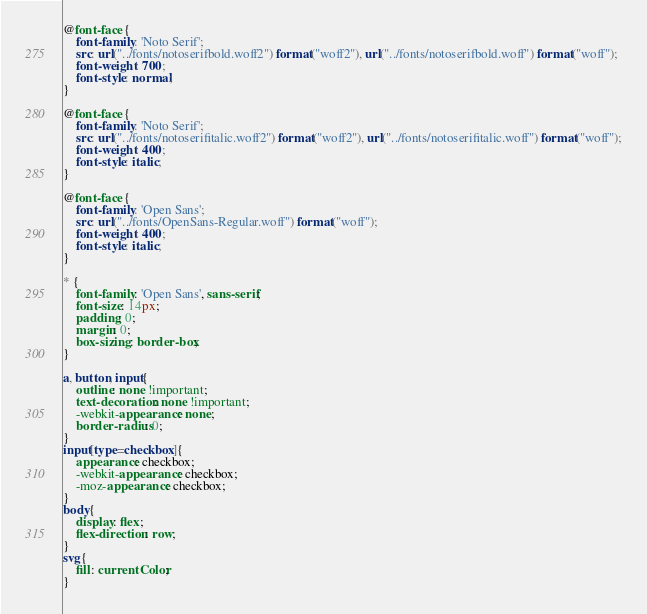Convert code to text. <code><loc_0><loc_0><loc_500><loc_500><_CSS_>@font-face {
    font-family: 'Noto Serif';
    src: url("../fonts/notoserifbold.woff2") format("woff2"), url("../fonts/notoserifbold.woff") format("woff");
    font-weight: 700;
    font-style: normal;
}

@font-face {
    font-family: 'Noto Serif';
    src: url("../fonts/notoserifitalic.woff2") format("woff2"), url("../fonts/notoserifitalic.woff") format("woff");
    font-weight: 400;
    font-style: italic;
}

@font-face {
    font-family: 'Open Sans';
    src: url("../fonts/OpenSans-Regular.woff") format("woff");
    font-weight: 400;
    font-style: italic;
}

* {
    font-family: 'Open Sans', sans-serif;
    font-size: 14px;
    padding: 0;
    margin: 0;
    box-sizing: border-box;
}

a, button, input{
    outline: none !important;
    text-decoration: none !important;
    -webkit-appearance: none;
    border-radius: 0;
}
input[type=checkbox]{
    appearance: checkbox;
    -webkit-appearance: checkbox;
    -moz-appearance: checkbox;
}
body{
    display: flex;
    flex-direction: row;
}
svg{
    fill: currentColor;
}
</code> 